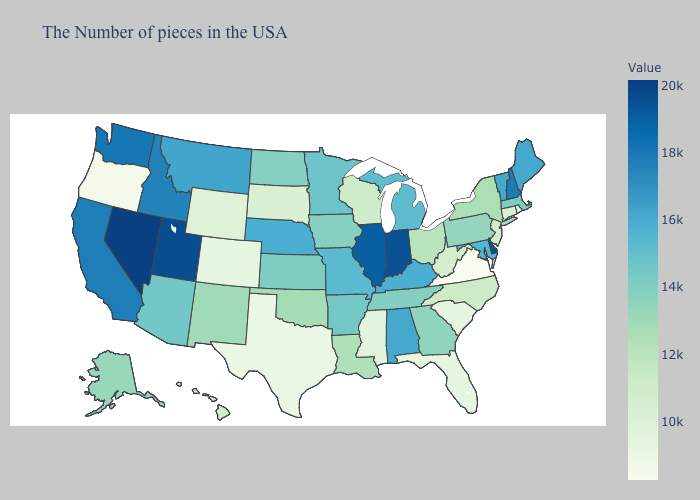Which states hav the highest value in the MidWest?
Answer briefly. Indiana. Does the map have missing data?
Be succinct. No. Which states have the lowest value in the South?
Write a very short answer. Virginia. Does Connecticut have the lowest value in the Northeast?
Write a very short answer. Yes. Does Nevada have the highest value in the USA?
Write a very short answer. Yes. 